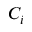<formula> <loc_0><loc_0><loc_500><loc_500>C _ { i }</formula> 